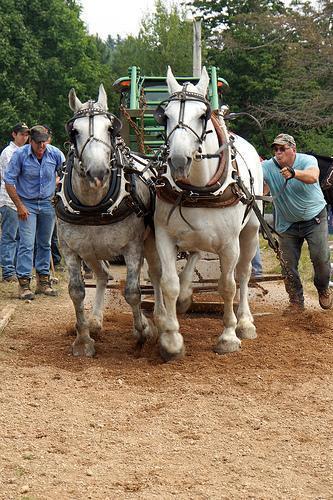How many horses are there?
Give a very brief answer. 2. 